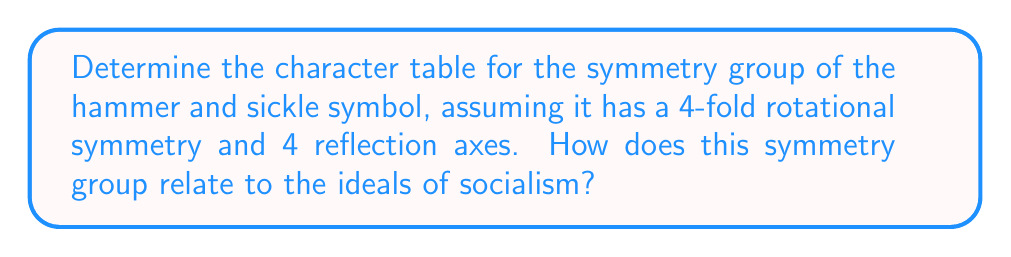Can you solve this math problem? Step 1: Identify the symmetry group
The symmetry group of the hammer and sickle symbol with 4-fold rotational symmetry and 4 reflection axes is isomorphic to the dihedral group $D_4$, which has 8 elements.

Step 2: List the conjugacy classes
The conjugacy classes of $D_4$ are:
- $\{e\}$ (identity)
- $\{r^2\}$ (180° rotation)
- $\{r, r^3\}$ (90° and 270° rotations)
- $\{s, sr^2\}$ (two reflections)
- $\{sr, sr^3\}$ (two diagonal reflections)

Step 3: Determine the irreducible representations
$D_4$ has 5 irreducible representations:
- Two 1-dimensional representations: trivial ($\chi_1$) and sign ($\chi_2$)
- Two 1-dimensional representations: $\chi_3$ and $\chi_4$
- One 2-dimensional representation: $\chi_5$

Step 4: Construct the character table
$$
\begin{array}{c|ccccc}
D_4 & \{e\} & \{r^2\} & \{r, r^3\} & \{s, sr^2\} & \{sr, sr^3\} \\
\hline
\chi_1 & 1 & 1 & 1 & 1 & 1 \\
\chi_2 & 1 & 1 & 1 & -1 & -1 \\
\chi_3 & 1 & 1 & -1 & 1 & -1 \\
\chi_4 & 1 & 1 & -1 & -1 & 1 \\
\chi_5 & 2 & -2 & 0 & 0 & 0
\end{array}
$$

Step 5: Relate to socialist ideals
The symmetry group $D_4$ reflects equality and balance in the hammer and sickle symbol. The 4-fold rotational symmetry represents the unity of workers from all directions, while the 4 reflection axes symbolize the equal treatment of all workers. The character table shows how these symmetries transform under different operations, emphasizing the mathematical structure underlying the symbol's representation of socialist ideals.
Answer: Character table for $D_4$:
$$
\begin{array}{c|ccccc}
D_4 & \{e\} & \{r^2\} & \{r, r^3\} & \{s, sr^2\} & \{sr, sr^3\} \\
\hline
\chi_1 & 1 & 1 & 1 & 1 & 1 \\
\chi_2 & 1 & 1 & 1 & -1 & -1 \\
\chi_3 & 1 & 1 & -1 & 1 & -1 \\
\chi_4 & 1 & 1 & -1 & -1 & 1 \\
\chi_5 & 2 & -2 & 0 & 0 & 0
\end{array}
$$ 